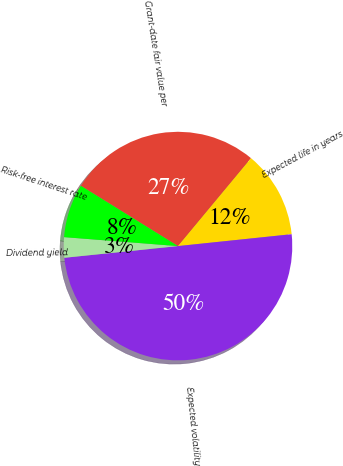Convert chart. <chart><loc_0><loc_0><loc_500><loc_500><pie_chart><fcel>Grant-date fair value per<fcel>Expected life in years<fcel>Expected volatility<fcel>Dividend yield<fcel>Risk-free interest rate<nl><fcel>27.19%<fcel>12.31%<fcel>50.02%<fcel>2.88%<fcel>7.59%<nl></chart> 